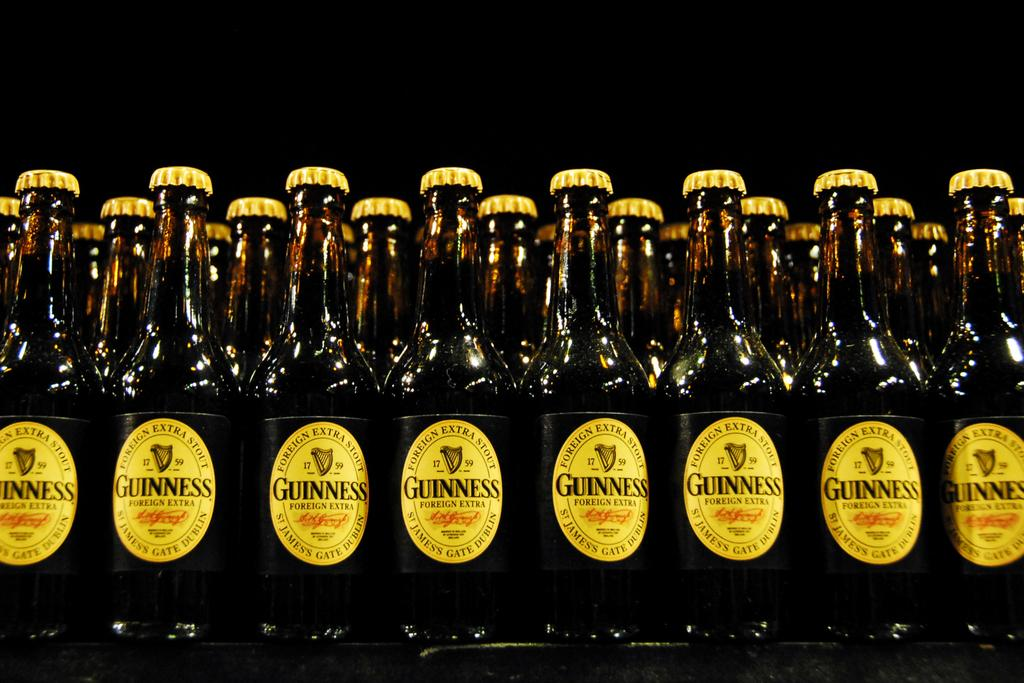Provide a one-sentence caption for the provided image. Several bottles of Guinness Ale sit on display in a store. 